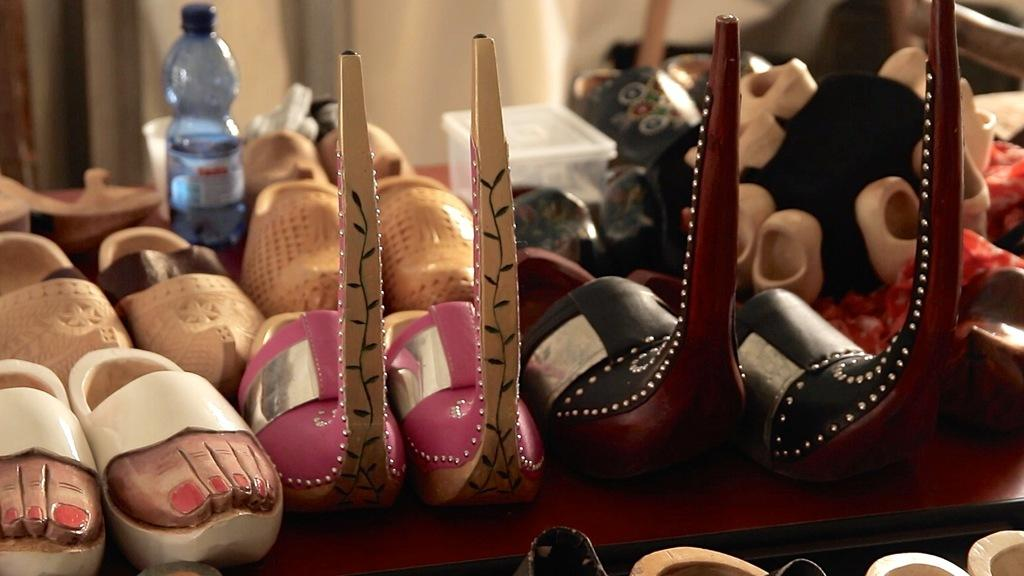What type of objects are on the table in the image? There are shoes, a bottle, a cup, and a box on the table in the image. Can you describe the container that is holding a liquid? There is a bottle in the image that is holding a liquid. What might be used for drinking in the image? There is a cup in the image that might be used for drinking. What type of object is used for storage in the image? There is a box in the image that is used for storage. What type of pickle is visible in the image? There is no pickle present in the image. What type of jewel is being used as a cup in the image? There is no jewel present in the image, and the cup is not made of a jewel. 